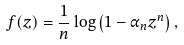Convert formula to latex. <formula><loc_0><loc_0><loc_500><loc_500>f ( z ) = \frac { 1 } { n } \log \left ( 1 - \alpha _ { n } z ^ { n } \right ) ,</formula> 